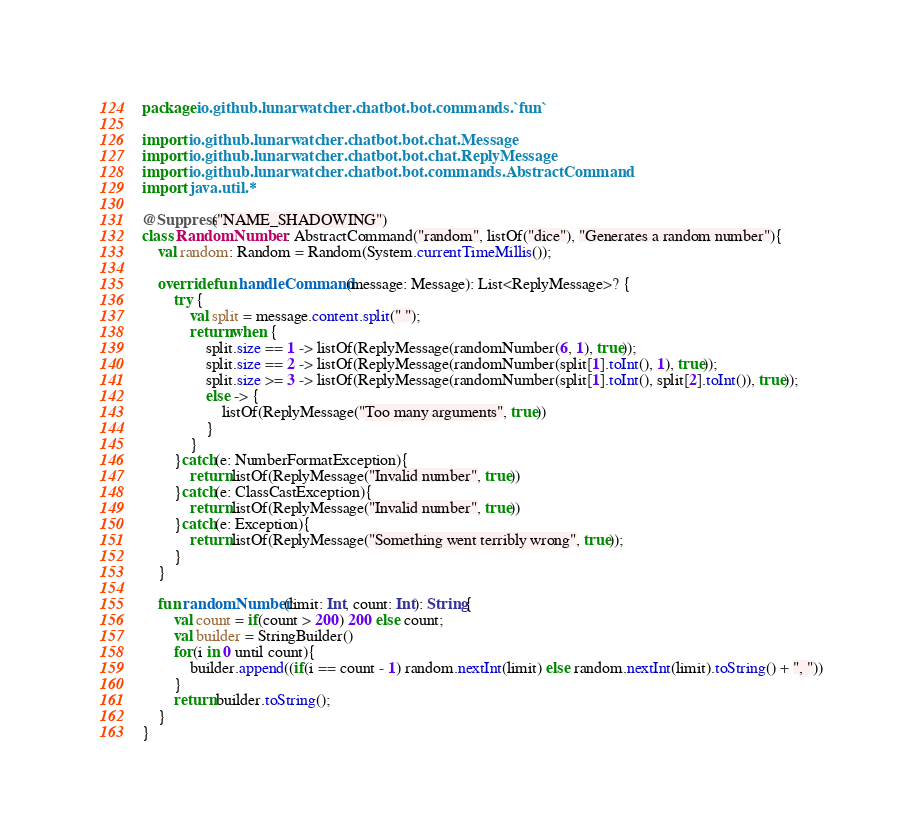<code> <loc_0><loc_0><loc_500><loc_500><_Kotlin_>package io.github.lunarwatcher.chatbot.bot.commands.`fun`

import io.github.lunarwatcher.chatbot.bot.chat.Message
import io.github.lunarwatcher.chatbot.bot.chat.ReplyMessage
import io.github.lunarwatcher.chatbot.bot.commands.AbstractCommand
import java.util.*

@Suppress("NAME_SHADOWING")
class RandomNumber : AbstractCommand("random", listOf("dice"), "Generates a random number"){
    val random: Random = Random(System.currentTimeMillis());

    override fun handleCommand(message: Message): List<ReplyMessage>? {
        try {
            val split = message.content.split(" ");
            return when {
                split.size == 1 -> listOf(ReplyMessage(randomNumber(6, 1), true));
                split.size == 2 -> listOf(ReplyMessage(randomNumber(split[1].toInt(), 1), true));
                split.size >= 3 -> listOf(ReplyMessage(randomNumber(split[1].toInt(), split[2].toInt()), true));
                else -> {
                    listOf(ReplyMessage("Too many arguments", true))
                }
            }
        }catch(e: NumberFormatException){
            return listOf(ReplyMessage("Invalid number", true))
        }catch(e: ClassCastException){
            return listOf(ReplyMessage("Invalid number", true))
        }catch(e: Exception){
            return listOf(ReplyMessage("Something went terribly wrong", true));
        }
    }

    fun randomNumber(limit: Int, count: Int): String{
        val count = if(count > 200) 200 else count;
        val builder = StringBuilder()
        for(i in 0 until count){
            builder.append((if(i == count - 1) random.nextInt(limit) else random.nextInt(limit).toString() + ", "))
        }
        return builder.toString();
    }
}</code> 